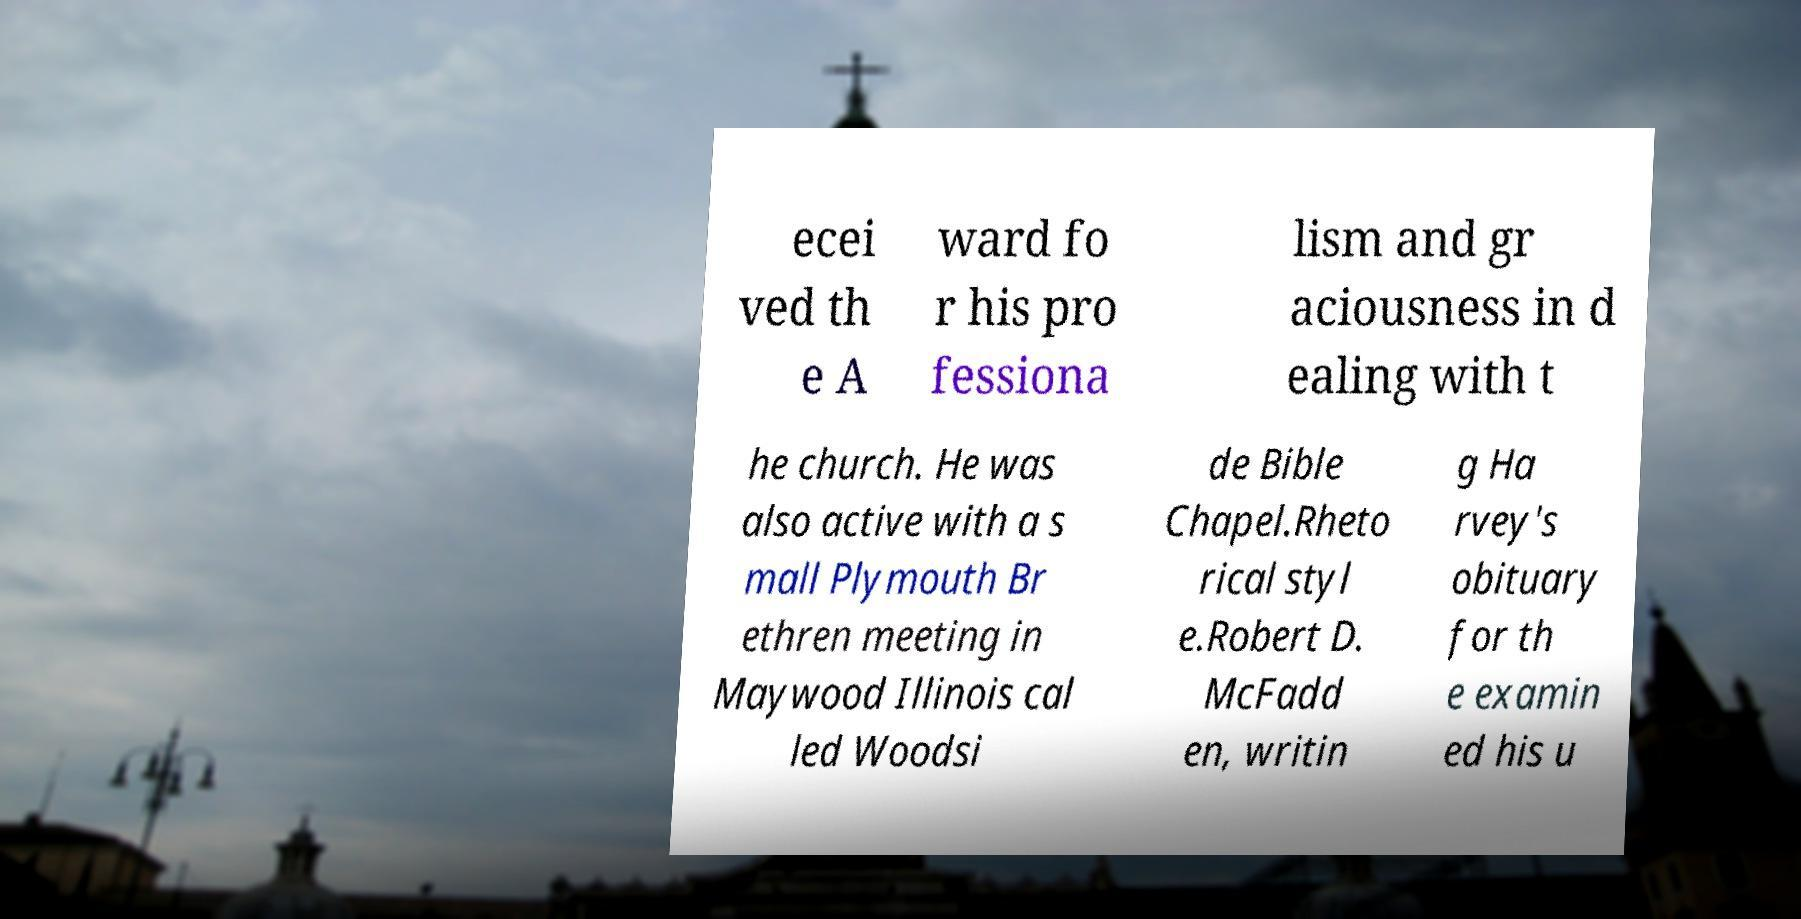There's text embedded in this image that I need extracted. Can you transcribe it verbatim? ecei ved th e A ward fo r his pro fessiona lism and gr aciousness in d ealing with t he church. He was also active with a s mall Plymouth Br ethren meeting in Maywood Illinois cal led Woodsi de Bible Chapel.Rheto rical styl e.Robert D. McFadd en, writin g Ha rvey's obituary for th e examin ed his u 